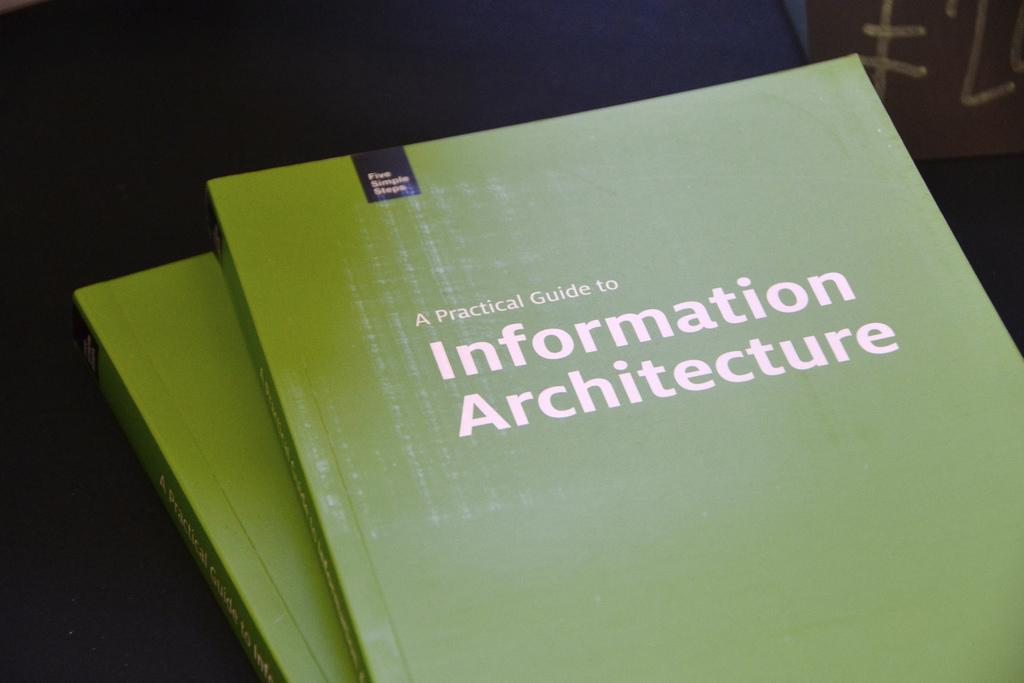<image>
Share a concise interpretation of the image provided. a green book that says a Practical guide to information 